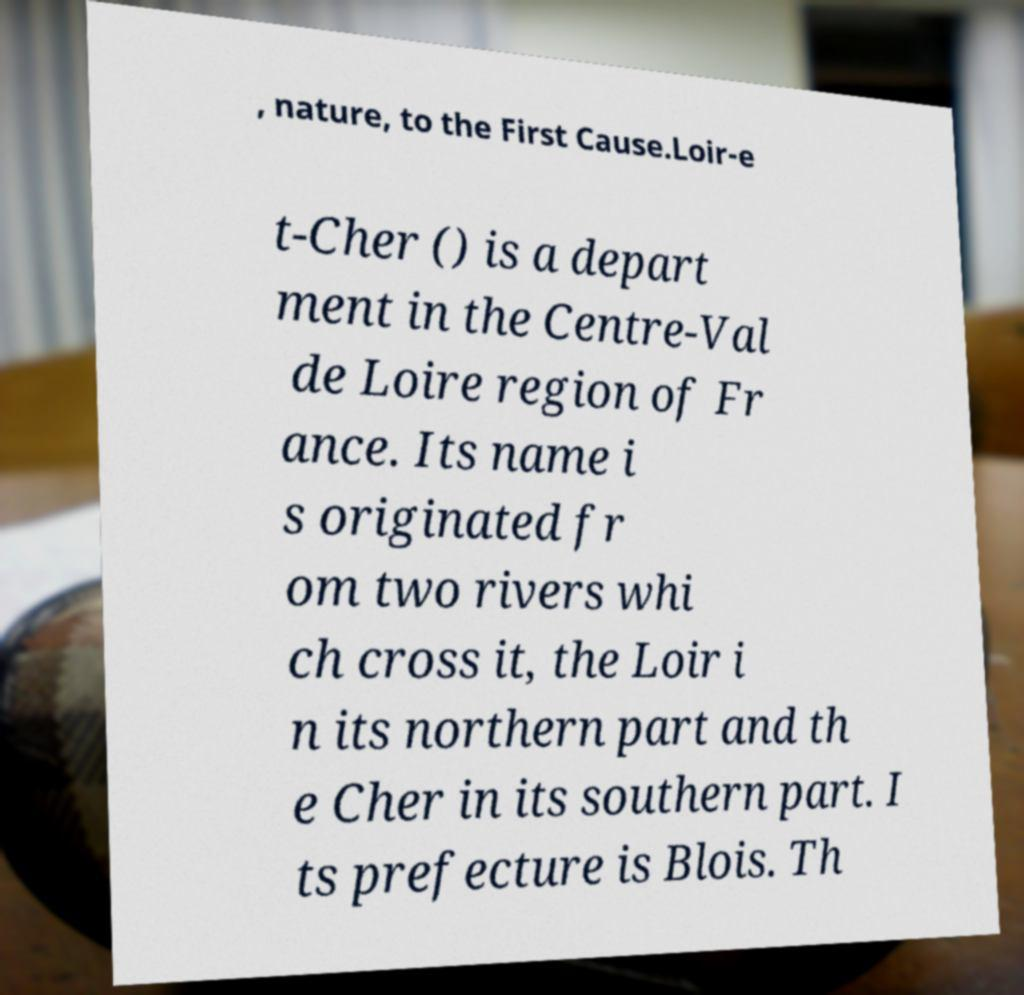Please identify and transcribe the text found in this image. , nature, to the First Cause.Loir-e t-Cher () is a depart ment in the Centre-Val de Loire region of Fr ance. Its name i s originated fr om two rivers whi ch cross it, the Loir i n its northern part and th e Cher in its southern part. I ts prefecture is Blois. Th 